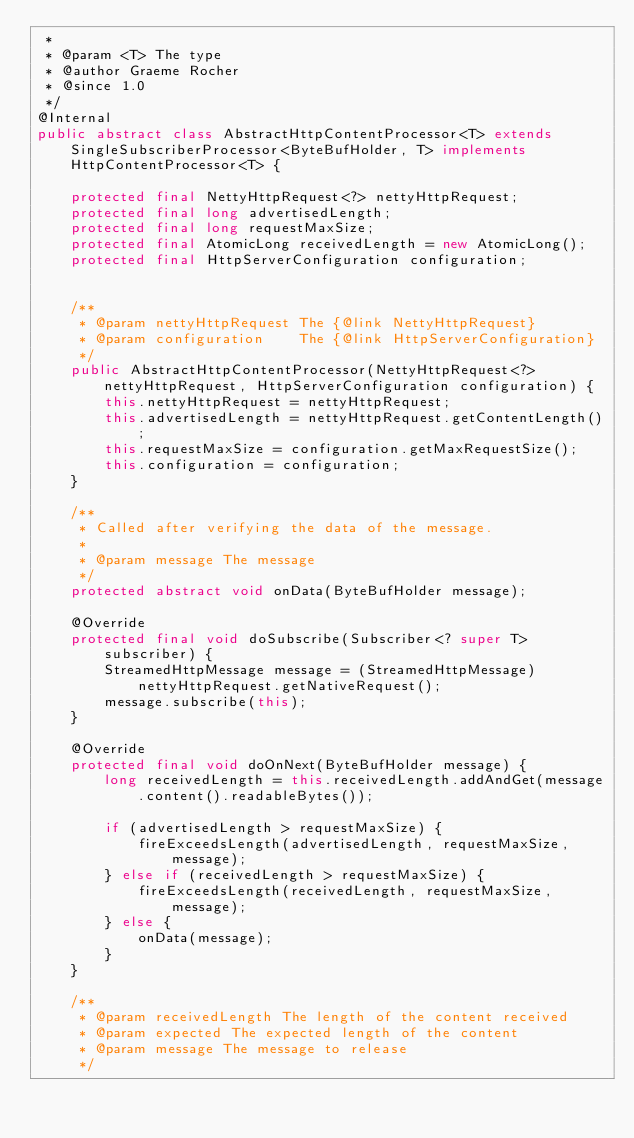Convert code to text. <code><loc_0><loc_0><loc_500><loc_500><_Java_> *
 * @param <T> The type
 * @author Graeme Rocher
 * @since 1.0
 */
@Internal
public abstract class AbstractHttpContentProcessor<T> extends SingleSubscriberProcessor<ByteBufHolder, T> implements HttpContentProcessor<T> {

    protected final NettyHttpRequest<?> nettyHttpRequest;
    protected final long advertisedLength;
    protected final long requestMaxSize;
    protected final AtomicLong receivedLength = new AtomicLong();
    protected final HttpServerConfiguration configuration;


    /**
     * @param nettyHttpRequest The {@link NettyHttpRequest}
     * @param configuration    The {@link HttpServerConfiguration}
     */
    public AbstractHttpContentProcessor(NettyHttpRequest<?> nettyHttpRequest, HttpServerConfiguration configuration) {
        this.nettyHttpRequest = nettyHttpRequest;
        this.advertisedLength = nettyHttpRequest.getContentLength();
        this.requestMaxSize = configuration.getMaxRequestSize();
        this.configuration = configuration;
    }

    /**
     * Called after verifying the data of the message.
     *
     * @param message The message
     */
    protected abstract void onData(ByteBufHolder message);

    @Override
    protected final void doSubscribe(Subscriber<? super T> subscriber) {
        StreamedHttpMessage message = (StreamedHttpMessage) nettyHttpRequest.getNativeRequest();
        message.subscribe(this);
    }

    @Override
    protected final void doOnNext(ByteBufHolder message) {
        long receivedLength = this.receivedLength.addAndGet(message.content().readableBytes());

        if (advertisedLength > requestMaxSize) {
            fireExceedsLength(advertisedLength, requestMaxSize, message);
        } else if (receivedLength > requestMaxSize) {
            fireExceedsLength(receivedLength, requestMaxSize, message);
        } else {
            onData(message);
        }
    }

    /**
     * @param receivedLength The length of the content received
     * @param expected The expected length of the content
     * @param message The message to release
     */</code> 